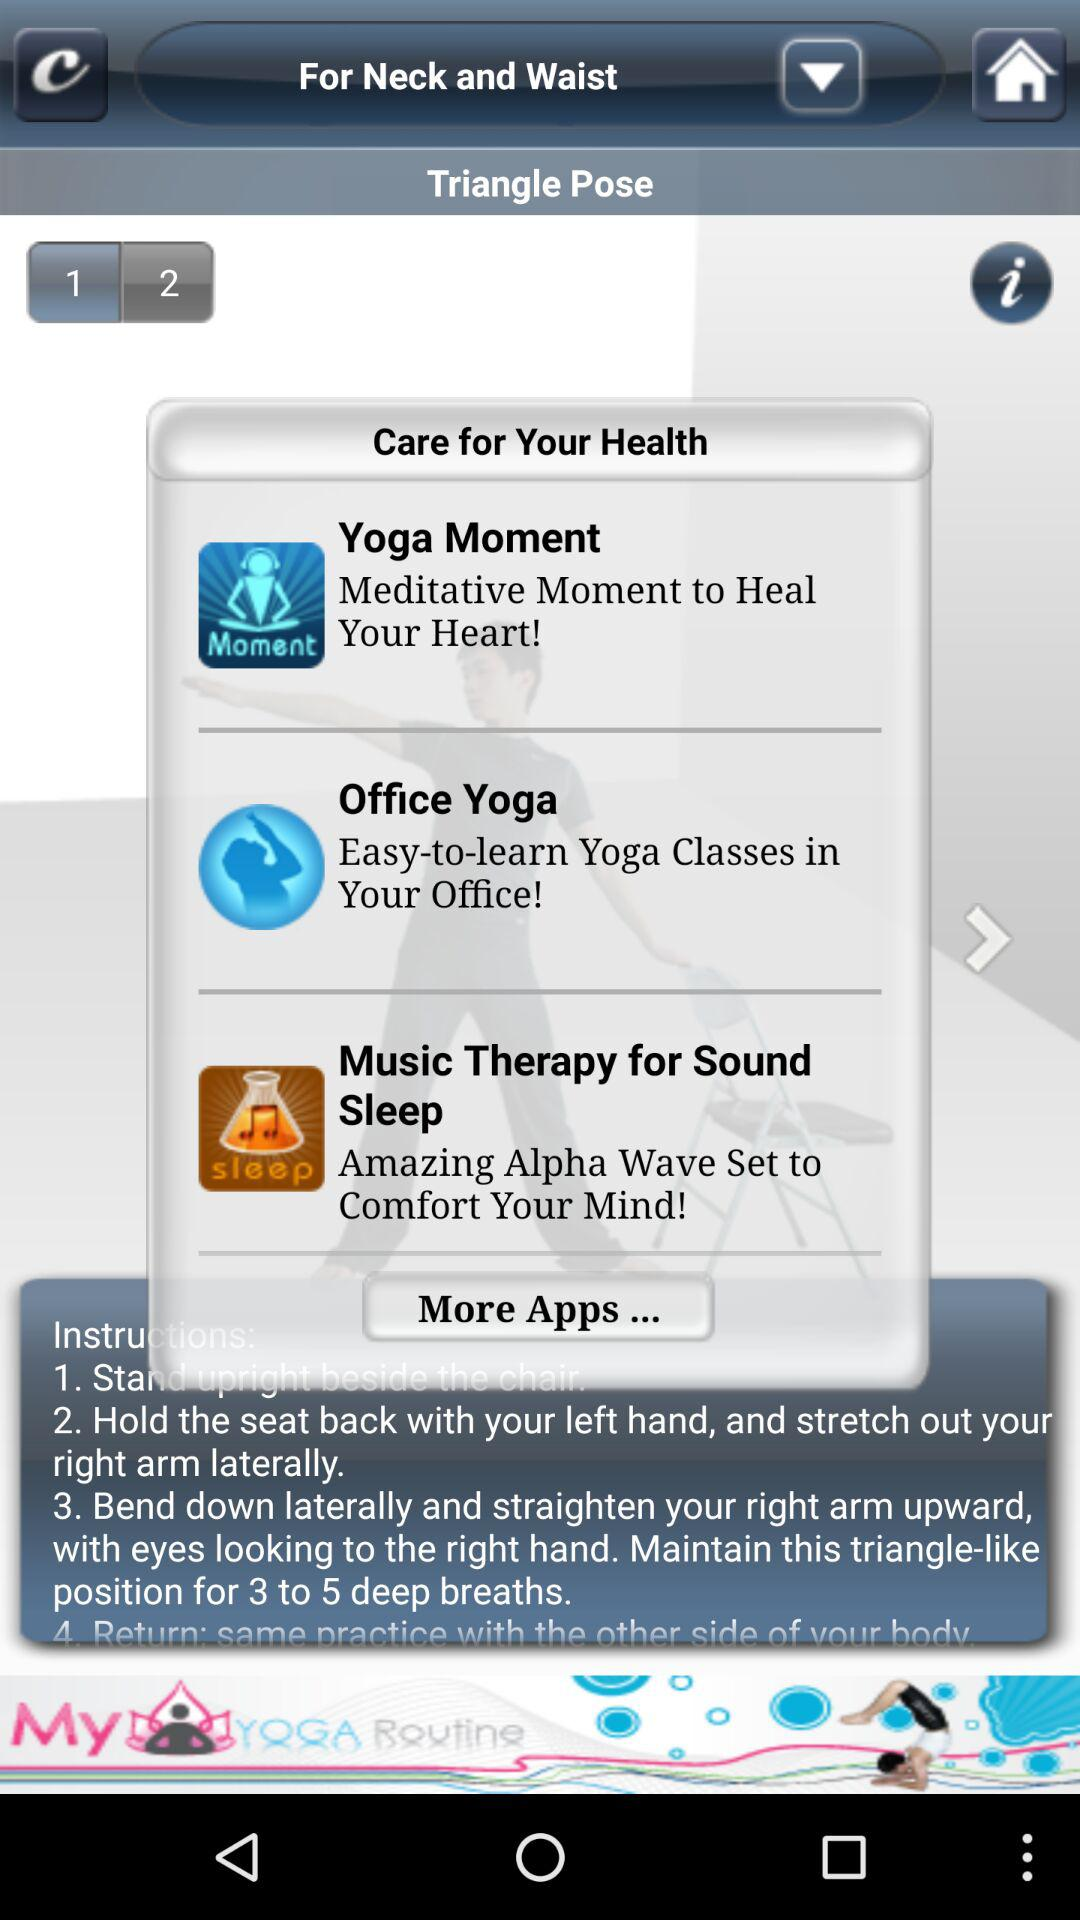How many instructions are there for Triangle Pose?
Answer the question using a single word or phrase. 4 